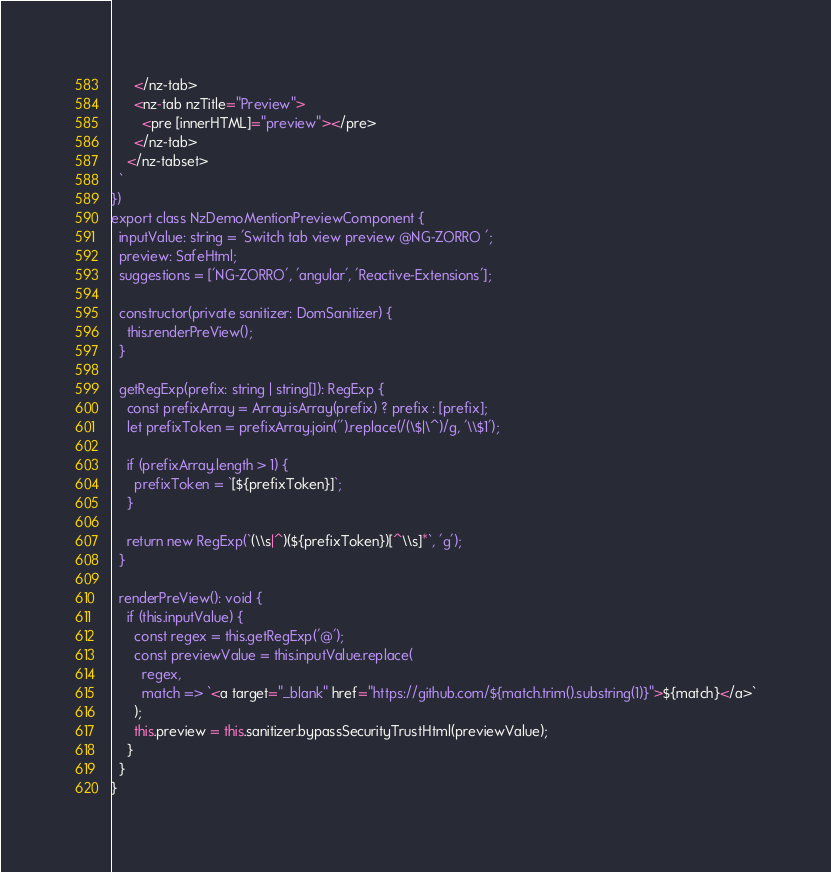<code> <loc_0><loc_0><loc_500><loc_500><_TypeScript_>      </nz-tab>
      <nz-tab nzTitle="Preview">
        <pre [innerHTML]="preview"></pre>
      </nz-tab>
    </nz-tabset>
  `
})
export class NzDemoMentionPreviewComponent {
  inputValue: string = 'Switch tab view preview @NG-ZORRO ';
  preview: SafeHtml;
  suggestions = ['NG-ZORRO', 'angular', 'Reactive-Extensions'];

  constructor(private sanitizer: DomSanitizer) {
    this.renderPreView();
  }

  getRegExp(prefix: string | string[]): RegExp {
    const prefixArray = Array.isArray(prefix) ? prefix : [prefix];
    let prefixToken = prefixArray.join('').replace(/(\$|\^)/g, '\\$1');

    if (prefixArray.length > 1) {
      prefixToken = `[${prefixToken}]`;
    }

    return new RegExp(`(\\s|^)(${prefixToken})[^\\s]*`, 'g');
  }

  renderPreView(): void {
    if (this.inputValue) {
      const regex = this.getRegExp('@');
      const previewValue = this.inputValue.replace(
        regex,
        match => `<a target="_blank" href="https://github.com/${match.trim().substring(1)}">${match}</a>`
      );
      this.preview = this.sanitizer.bypassSecurityTrustHtml(previewValue);
    }
  }
}
</code> 